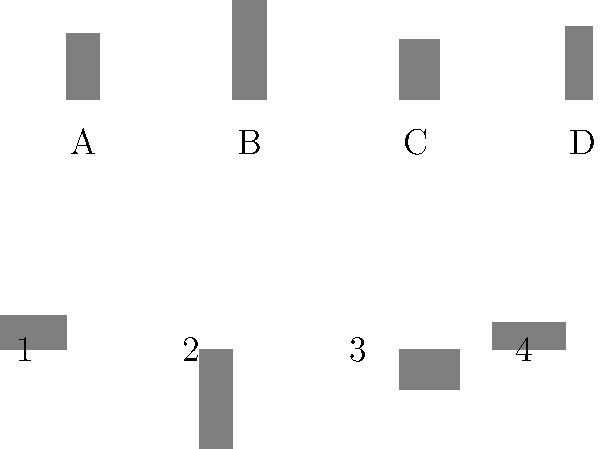Match the rotated character silhouettes (1-4) with their original positions (A-D). Which rotated silhouette corresponds to Rebecca's character? To solve this spatial intelligence question, we need to analyze the silhouettes and their rotated counterparts:

1. Identify the original silhouettes:
   A: Ted Lasso (shorter, square shape)
   B: Rebecca (taller, rectangular shape)
   C: Roy (broader, slightly shorter than Rebecca)
   D: Keeley (slimmer, slightly taller than Ted)

2. Analyze the rotated silhouettes:
   1: Rotated 90° clockwise (Ted)
   2: Rotated 180° (Rebecca)
   3: Rotated 270° clockwise (Roy)
   4: Rotated 90° clockwise (Keeley)

3. Match the rotated silhouettes to their originals:
   1 matches A (Ted)
   2 matches B (Rebecca)
   3 matches C (Roy)
   4 matches D (Keeley)

4. Identify Rebecca's rotated silhouette:
   Rebecca's original silhouette is B, which corresponds to the rotated silhouette 2.

This question tests spatial reasoning skills while incorporating "Ted Lasso" character recognition, appealing to the persona's interest in analyzing character developments.
Answer: 2 